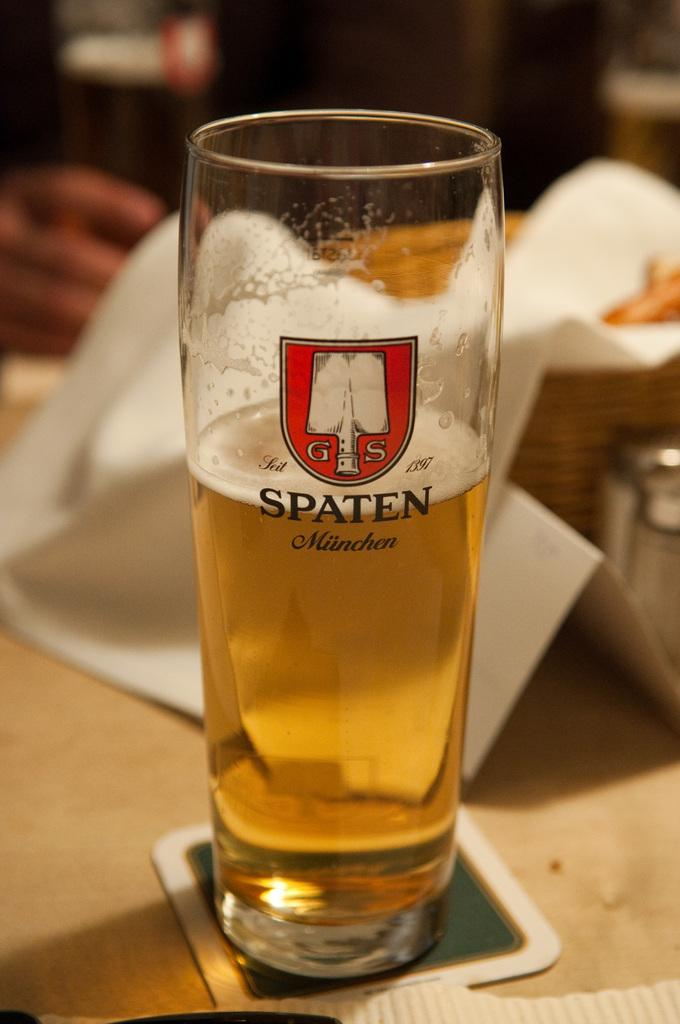What is inside the glass that is visible in the image? There is a glass filled with liquid in the image. What other items can be seen on the surface in the image? There are tissues on the surface in the image. How many pears are on the surface in the image? There are no pears present in the image. What is the rate at which the liquid in the glass is evaporating in the image? The rate of evaporation cannot be determined from the image, as there is no indication of time passing or environmental factors affecting the liquid. 